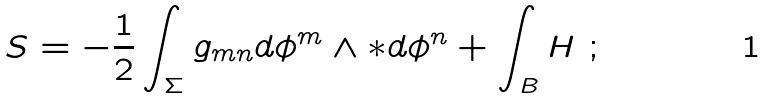Convert formula to latex. <formula><loc_0><loc_0><loc_500><loc_500>S = - \frac { 1 } { 2 } \int _ { \Sigma } g _ { m n } d \phi ^ { m } \wedge * d \phi ^ { n } + \int _ { B } H \ ;</formula> 